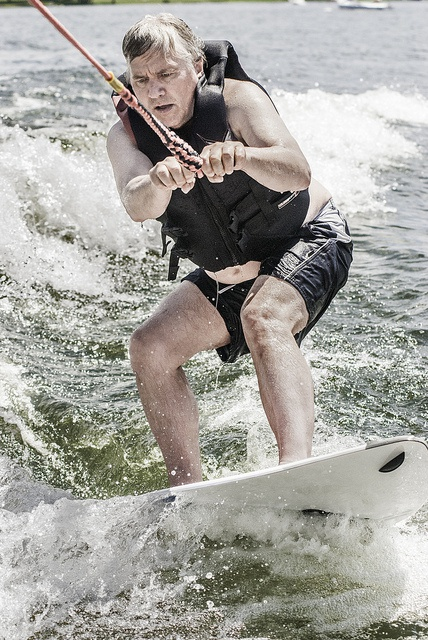Describe the objects in this image and their specific colors. I can see people in olive, black, darkgray, lightgray, and gray tones and surfboard in olive, darkgray, lightgray, and gray tones in this image. 